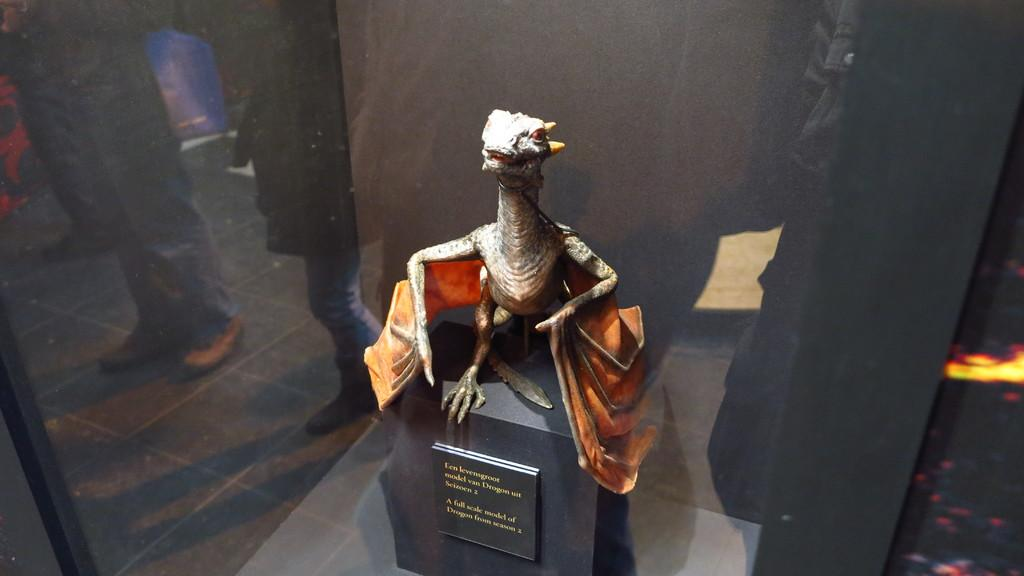What is the main subject of the image? There is a depiction of a dinosaur in the center of the image. What else can be seen on the object with the dinosaur? There is text on the object with the dinosaur. What is visible in the background of the image? There are people standing in the background of the image. What is the people's position in relation to the floor? The people are standing on the floor. What type of apparel is the dinosaur wearing in the image? The dinosaur is not a living creature and therefore cannot wear apparel. --- Facts: 1. There is a person holding a book in the image. 2. The person is sitting on a chair. 3. The book has a blue cover. 4. There is a table next to the chair. 5. The table has a lamp on it. Absurd Topics: animal, ocean, dance Conversation: What is the person in the image holding? The person is holding a book in the image. What is the person's position in relation to the chair? The person is sitting on a chair. What color is the book's cover? The book has a blue cover. What is on the table next to the chair? There is a lamp on the table next to the chair. Reasoning: Let's think step by step in order to produce the conversation. We start by identifying the main subject of the image, which is the person holding a book. Then, we describe the person's position on the chair. Next, we mention the color of the book's cover. Finally, we describe the object on the table next to the chair. Each question is designed to elicit a specific detail about the image that is known from the provided facts. Absurd Question/Answer: Can you see any animals swimming in the ocean in the image? There is no ocean or animals present in the image. --- Facts: 1. There is a group of people standing in a circle in the image. 2. The people are holding hands. 3. The people are wearing matching shirts. 4. There is a banner in the background of the image. 5. The banner has text on it. Absurd Topics: snow, parrot, bicycle Conversation: What are the people in the image doing? The people in the image are standing in a circle and holding hands. What are the people wearing in the image? The people are wearing matching shirts in the image. What is visible in the background of the image? There is a banner in the background of the image. What is written on the banner? The banner has text on it. Reasoning: Let's think step by step in order to produce the 